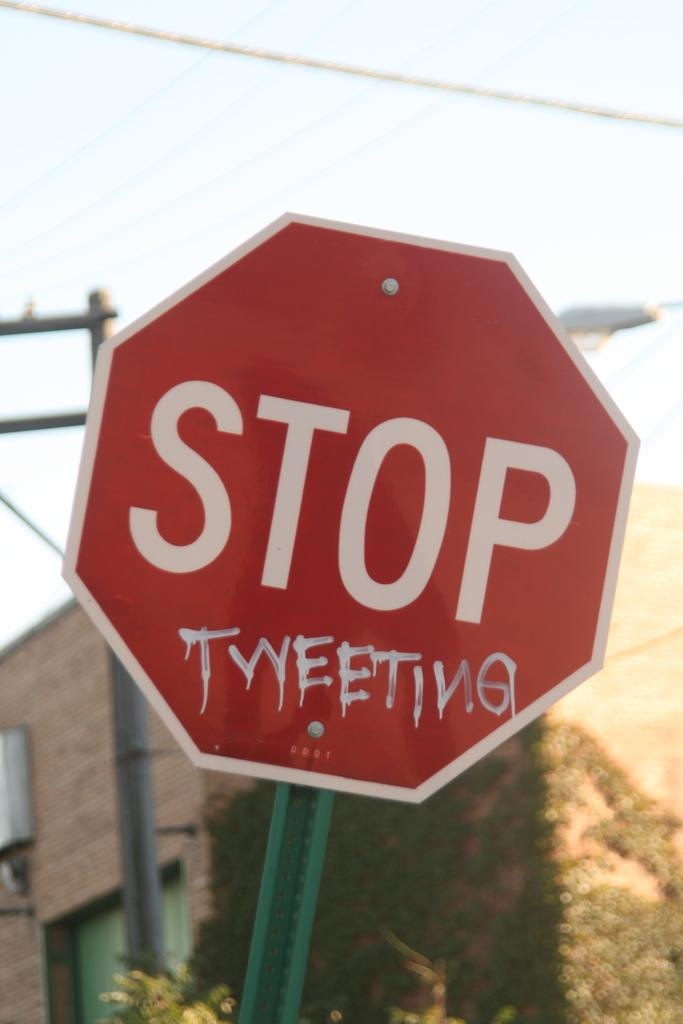<image>
Give a short and clear explanation of the subsequent image. A red stop sign has graffiti painted on it in white letters that say Tweeting. 